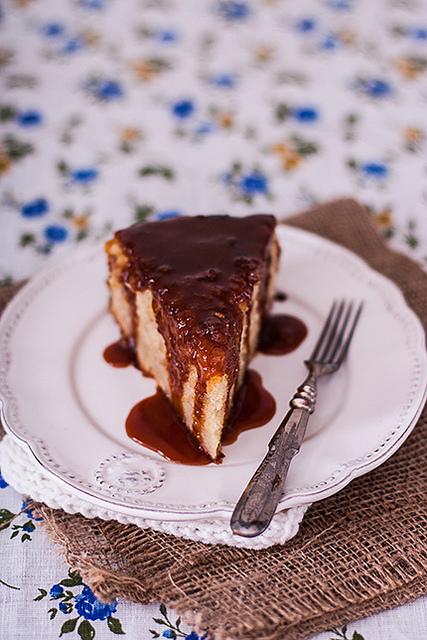What type of dessert is this?
Short answer required. Cheesecake. Has anyone taken a bit out of this dessert?
Answer briefly. No. Does this cake appear to be vanilla flavored?
Give a very brief answer. Yes. What fabric is the napkin?
Write a very short answer. Burlap. 